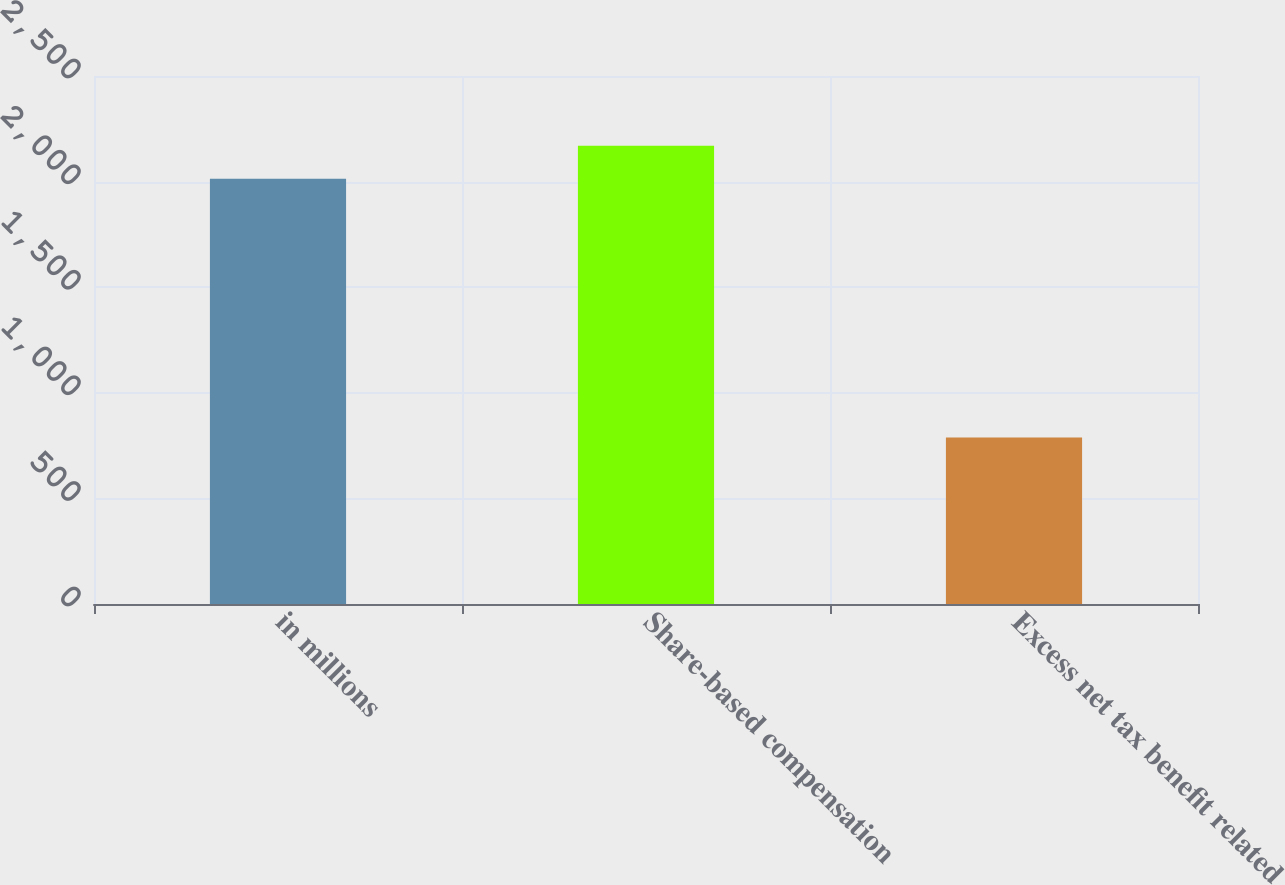<chart> <loc_0><loc_0><loc_500><loc_500><bar_chart><fcel>in millions<fcel>Share-based compensation<fcel>Excess net tax benefit related<nl><fcel>2014<fcel>2169.2<fcel>788<nl></chart> 